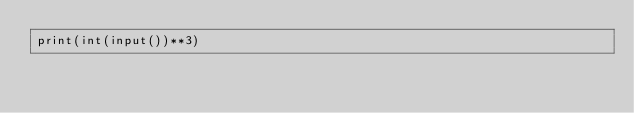<code> <loc_0><loc_0><loc_500><loc_500><_Python_>print(int(input())**3)</code> 